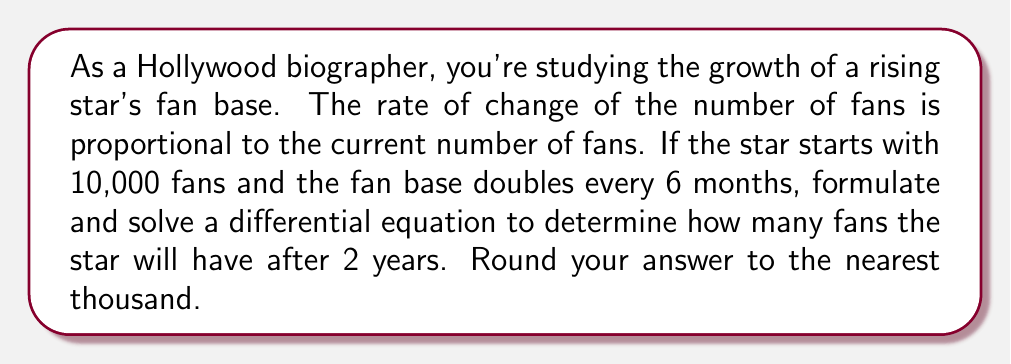Teach me how to tackle this problem. Let's approach this step-by-step:

1) Let $N(t)$ be the number of fans at time $t$ (in months).

2) Given: The rate of change of fans is proportional to the current number of fans. This can be expressed as:

   $$\frac{dN}{dt} = kN$$

   where $k$ is the growth constant.

3) We're told that the fan base doubles every 6 months. Let's use this to find $k$:

   $$N(6) = 2N(0)$$
   $$N(0)e^{6k} = 2N(0)$$
   $$e^{6k} = 2$$
   $$6k = \ln(2)$$
   $$k = \frac{\ln(2)}{6} \approx 0.1155$$

4) Now we can write our full differential equation:

   $$\frac{dN}{dt} = \frac{\ln(2)}{6}N$$

5) The general solution to this equation is:

   $$N(t) = Ce^{\frac{\ln(2)}{6}t}$$

6) Using the initial condition $N(0) = 10000$, we can find $C$:

   $$10000 = Ce^{0}$$
   $$C = 10000$$

7) So our particular solution is:

   $$N(t) = 10000e^{\frac{\ln(2)}{6}t}$$

8) To find the number of fans after 2 years (24 months), we calculate:

   $$N(24) = 10000e^{\frac{\ln(2)}{6}(24)}$$
   $$= 10000e^{4\ln(2)}$$
   $$= 10000(2^4)$$
   $$= 160000$$

9) Rounding to the nearest thousand gives us 160,000 fans.
Answer: 160,000 fans 